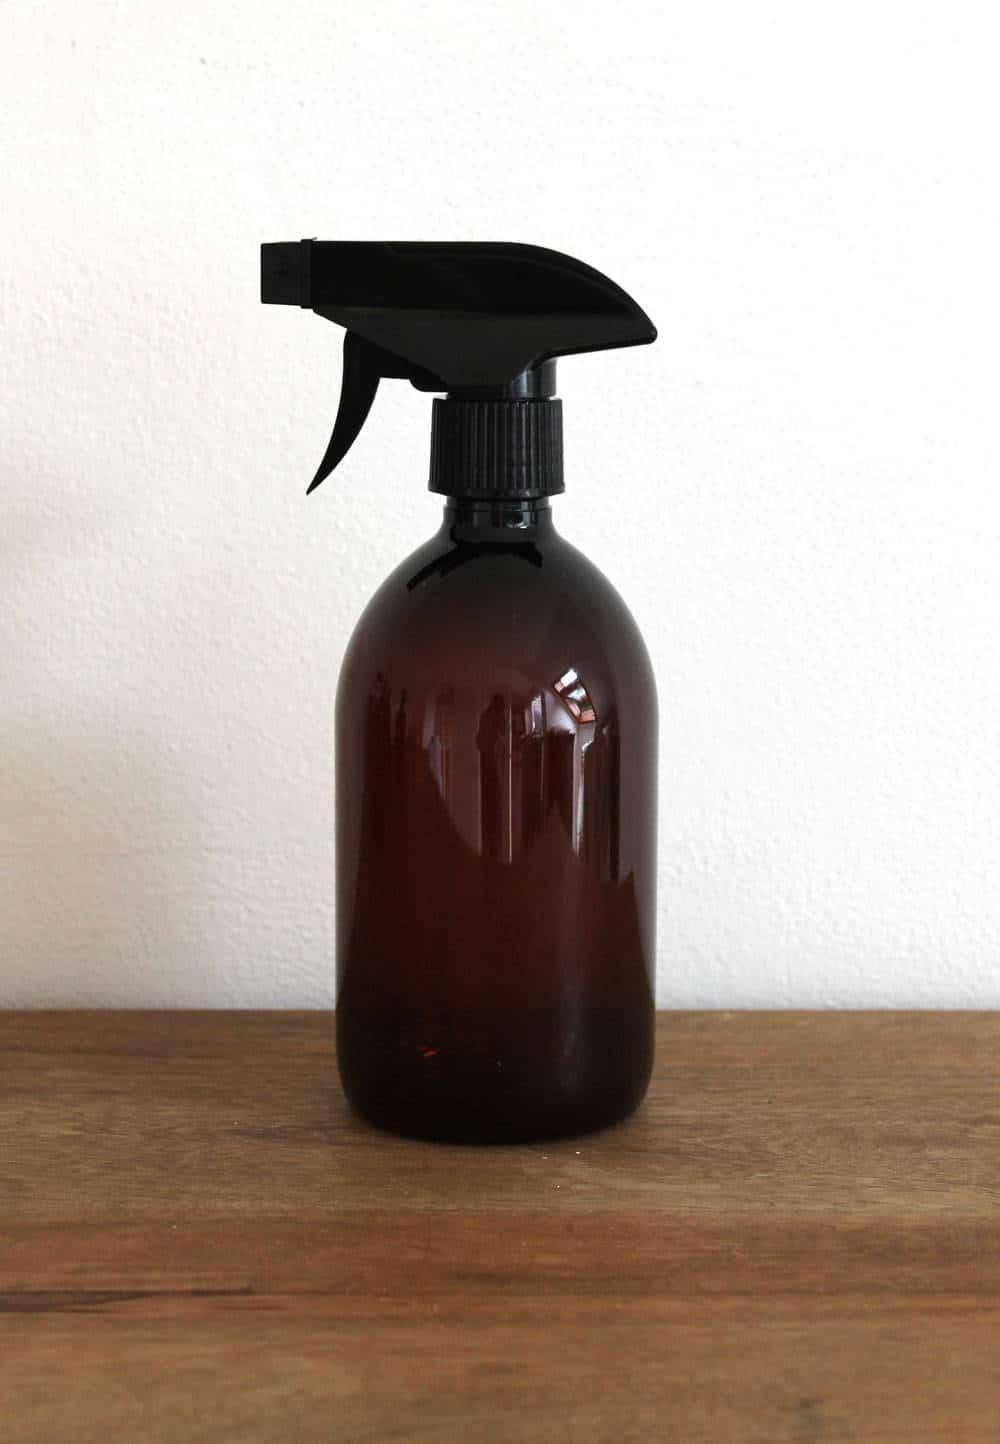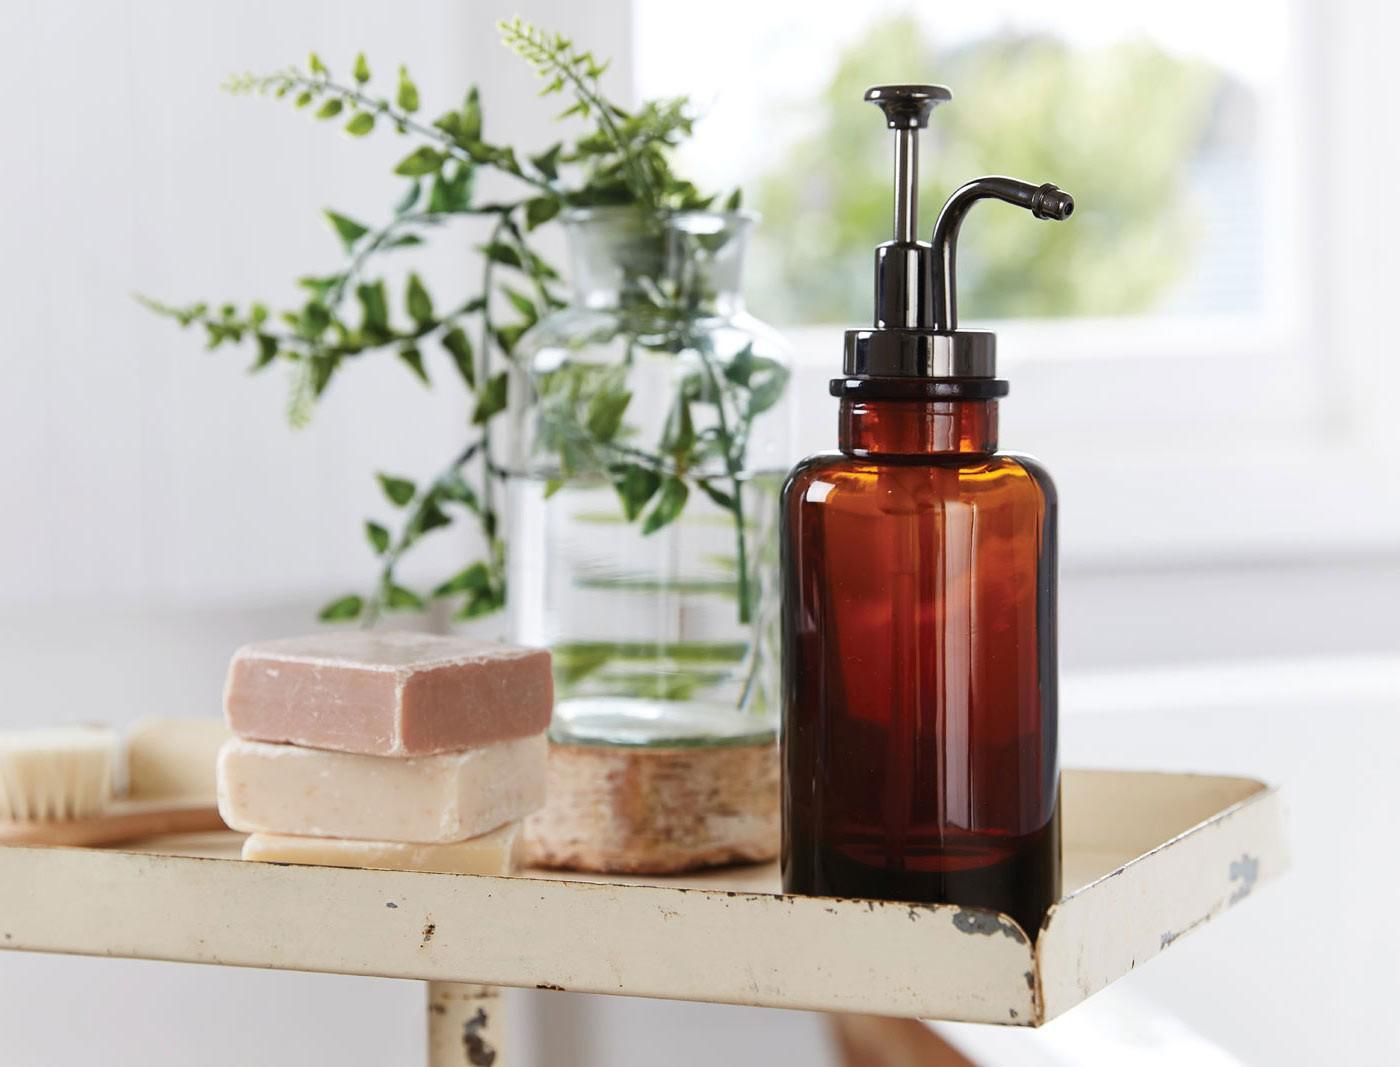The first image is the image on the left, the second image is the image on the right. Considering the images on both sides, is "There is a plant to the left of one of the bottles, and one of the bottles is on a wooden surface." valid? Answer yes or no. Yes. 